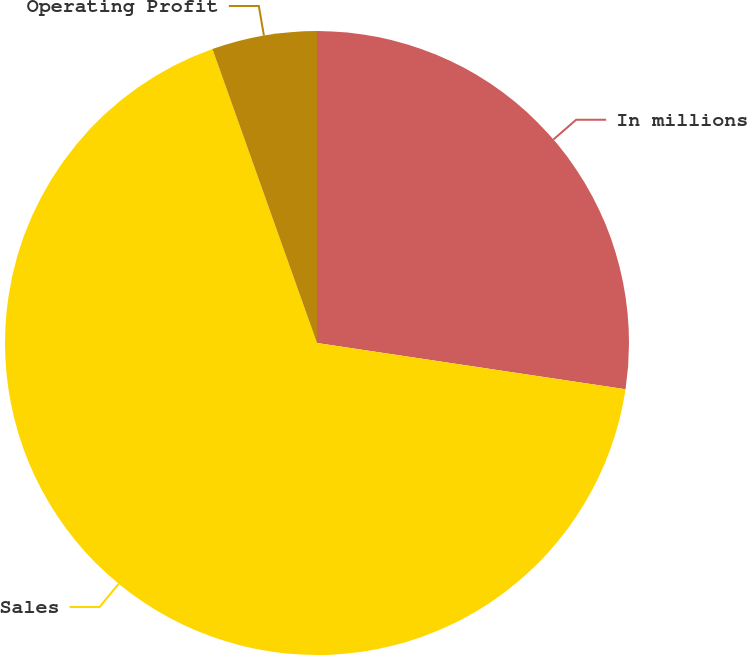Convert chart to OTSL. <chart><loc_0><loc_0><loc_500><loc_500><pie_chart><fcel>In millions<fcel>Sales<fcel>Operating Profit<nl><fcel>27.37%<fcel>67.19%<fcel>5.44%<nl></chart> 